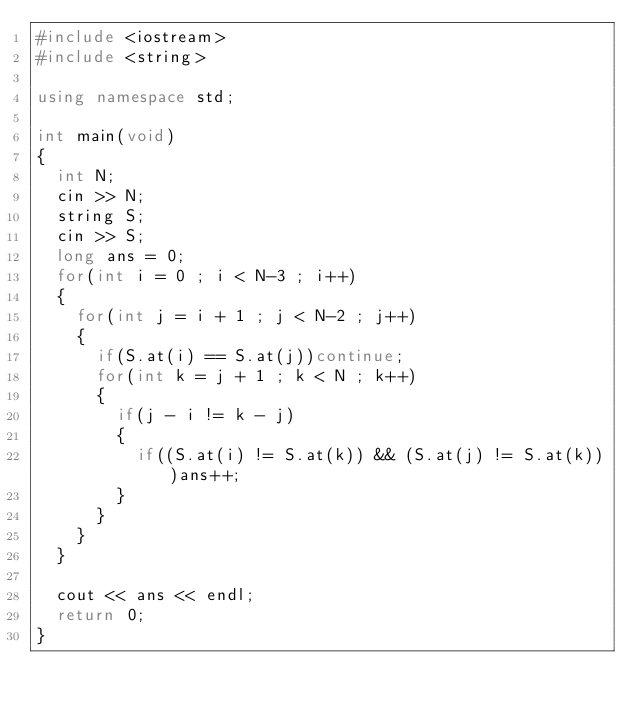<code> <loc_0><loc_0><loc_500><loc_500><_C++_>#include <iostream>
#include <string>

using namespace std;

int main(void)
{
  int N;
  cin >> N;
  string S;
  cin >> S;
  long ans = 0;
  for(int i = 0 ; i < N-3 ; i++)
  {
    for(int j = i + 1 ; j < N-2 ; j++)
    {
      if(S.at(i) == S.at(j))continue;
      for(int k = j + 1 ; k < N ; k++)
      {
        if(j - i != k - j)
        {
          if((S.at(i) != S.at(k)) && (S.at(j) != S.at(k)))ans++;
        }
      }
    }
  }
  
  cout << ans << endl;
  return 0;
}
</code> 